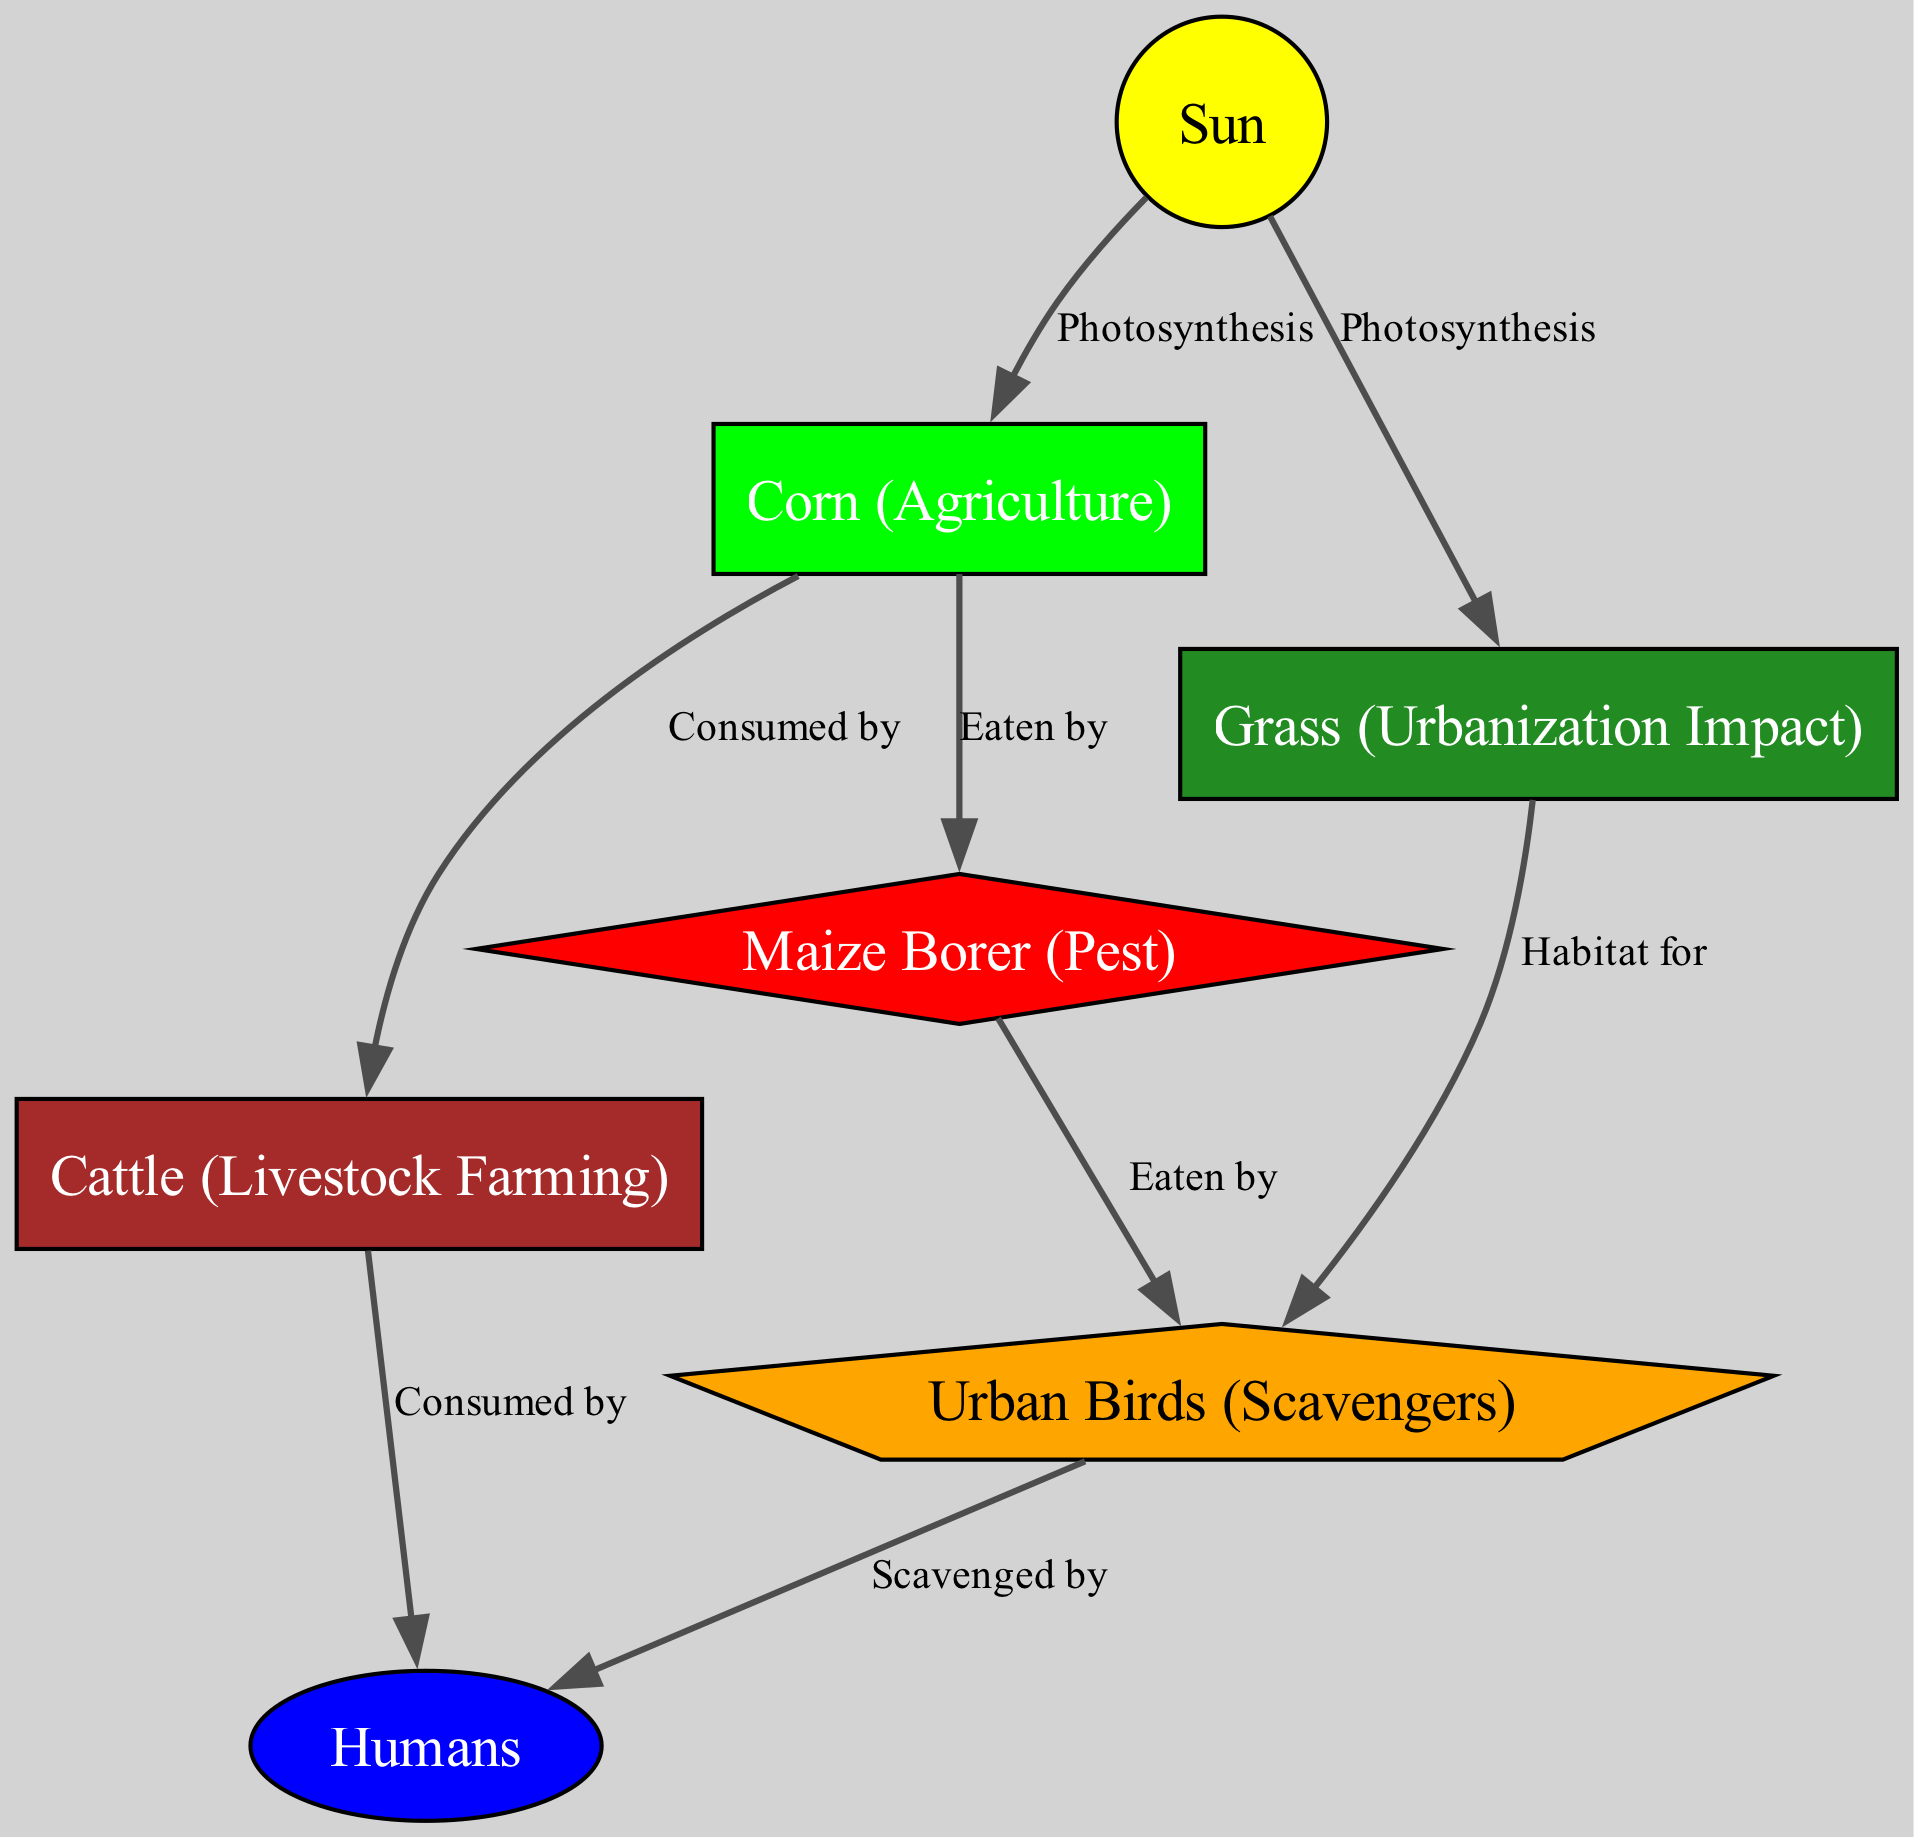What is the primary source of energy in the food chain? The diagram indicates that the "Sun" is the primary node that provides energy, as all other nodes derive energy through photosynthesis from it.
Answer: Sun How many nodes are in the diagram? By counting each distinct item in the "nodes" section of the data, there are a total of seven nodes present in the diagram.
Answer: 7 What do cattle consume according to the diagram? The edge from "corn" to "cattle" denotes that "cattle" are consumed by "corn", indicating the direct relationship in the food chain.
Answer: Corn What type of birds are represented in urban areas? "Urban Birds" are specifically labeled as scavengers in the illustration, highlighting their role in the urban ecosystem interacting with food sources.
Answer: Urban Birds How many edges are connecting the nodes in the diagram? By totaling the connections listed in the "edges" section, there are eight distinct edges that connect the various nodes in the food chain diagram.
Answer: 8 What relationship exists between maize borers and urban birds? The diagram shows an edge connecting "maize_borer" to "urban_birds," indicating that maize borers are a food source that urban birds eat, exemplifying the flow of energy in this part of the chain.
Answer: Eaten by Who consumes cattle as depicted in the diagram? There is an edge going from "cattle" leading to "humans," signifying that humans consume cattle as part of their food sources, illustrating a direct connection in the food chain.
Answer: Humans What role does grass play in the urban ecosystem? The edge between "grass" and "urban_birds" indicates that grass provides habitat for urban birds, showcasing its ecological function beyond mere food sources.
Answer: Habitat for What organism is affected by agriculture through predation as shown in the diagram? The relationship indicates that "maize_borer" is depicted as being preyed upon by "urban_birds," connecting agriculture impacts with natural predation dynamics.
Answer: Eaten by 